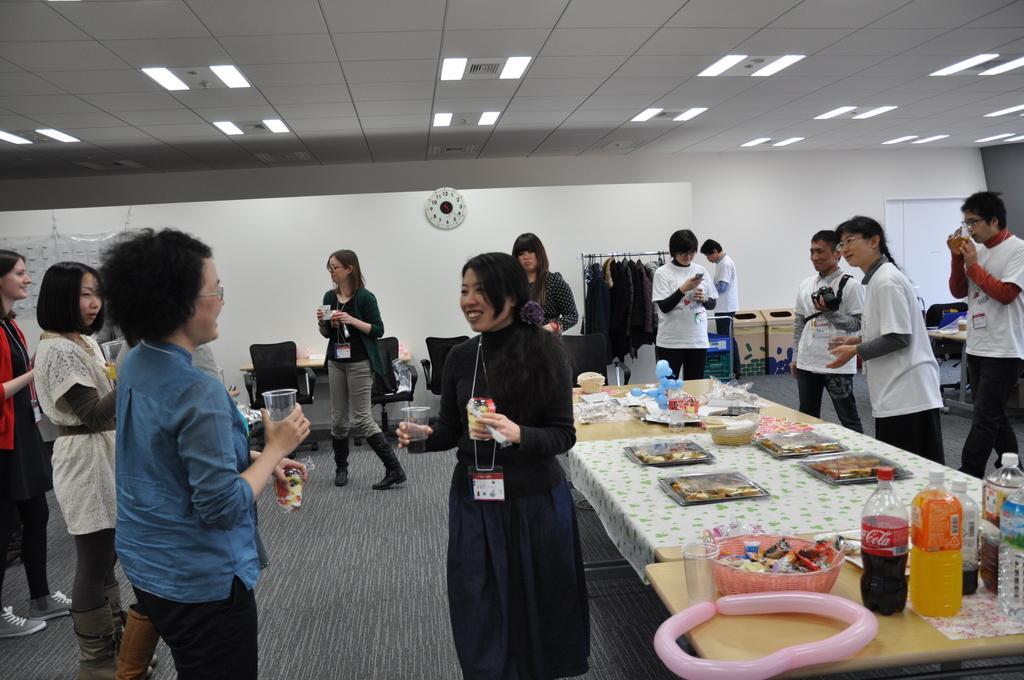In one or two sentences, can you explain what this image depicts? In this image I see people standing and few of them are smiling, I can also see that there is a table over here and few things on it. In the background I can see the chairs, wall, a clock, few clothes and the lights. 